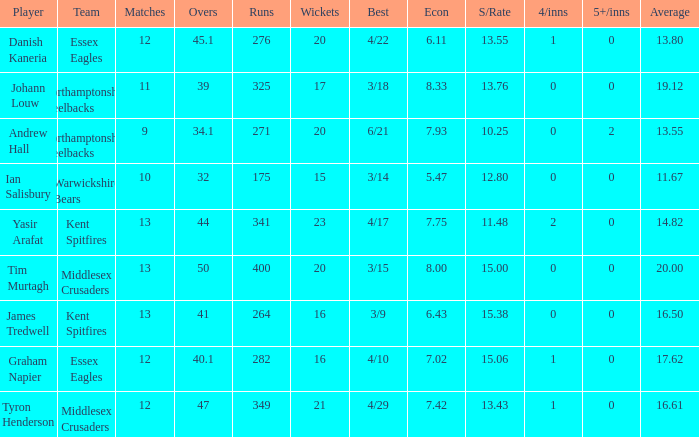Name the least matches for runs being 276 12.0. 